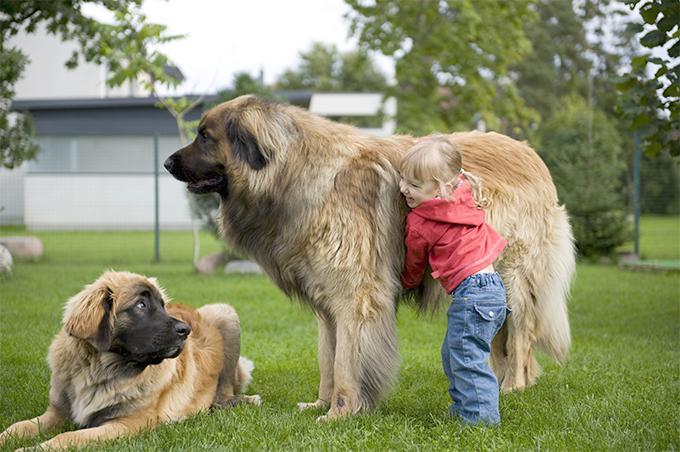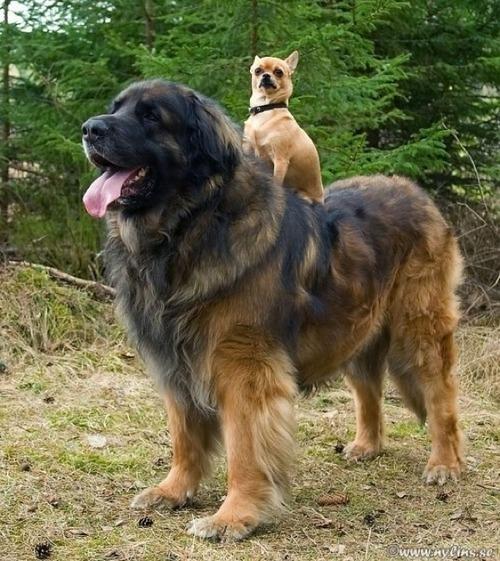The first image is the image on the left, the second image is the image on the right. Assess this claim about the two images: "there is a child in the image on the left". Correct or not? Answer yes or no. Yes. The first image is the image on the left, the second image is the image on the right. For the images shown, is this caption "In one image, an adult is standing behind a large dog that has its mouth open." true? Answer yes or no. No. 